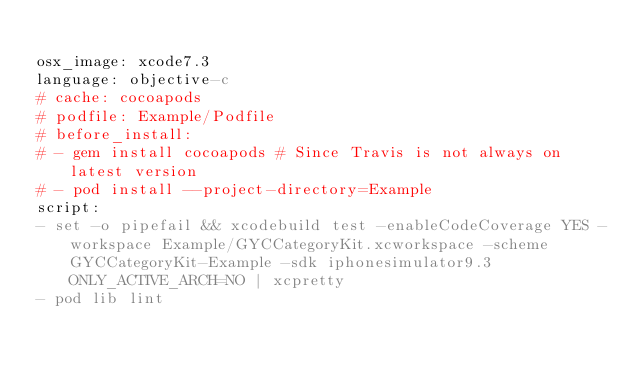Convert code to text. <code><loc_0><loc_0><loc_500><loc_500><_YAML_>
osx_image: xcode7.3
language: objective-c
# cache: cocoapods
# podfile: Example/Podfile
# before_install:
# - gem install cocoapods # Since Travis is not always on latest version
# - pod install --project-directory=Example
script:
- set -o pipefail && xcodebuild test -enableCodeCoverage YES -workspace Example/GYCCategoryKit.xcworkspace -scheme GYCCategoryKit-Example -sdk iphonesimulator9.3 ONLY_ACTIVE_ARCH=NO | xcpretty
- pod lib lint
</code> 